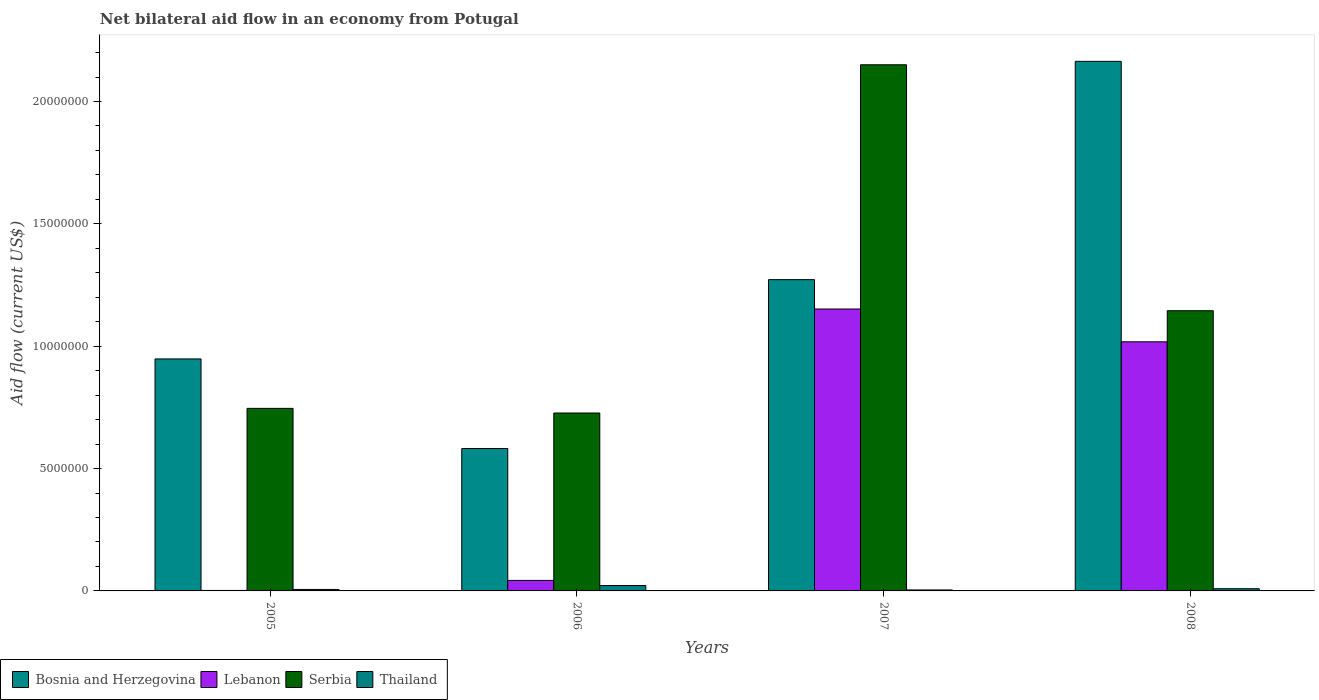How many different coloured bars are there?
Make the answer very short. 4. How many groups of bars are there?
Keep it short and to the point. 4. Are the number of bars per tick equal to the number of legend labels?
Provide a succinct answer. Yes. What is the label of the 3rd group of bars from the left?
Your answer should be compact. 2007. In how many cases, is the number of bars for a given year not equal to the number of legend labels?
Provide a short and direct response. 0. What is the net bilateral aid flow in Bosnia and Herzegovina in 2007?
Keep it short and to the point. 1.27e+07. Across all years, what is the maximum net bilateral aid flow in Serbia?
Your answer should be compact. 2.15e+07. Across all years, what is the minimum net bilateral aid flow in Bosnia and Herzegovina?
Offer a terse response. 5.82e+06. In which year was the net bilateral aid flow in Bosnia and Herzegovina maximum?
Give a very brief answer. 2008. What is the total net bilateral aid flow in Bosnia and Herzegovina in the graph?
Ensure brevity in your answer.  4.97e+07. What is the difference between the net bilateral aid flow in Bosnia and Herzegovina in 2007 and that in 2008?
Offer a very short reply. -8.92e+06. What is the difference between the net bilateral aid flow in Serbia in 2008 and the net bilateral aid flow in Thailand in 2006?
Give a very brief answer. 1.12e+07. What is the average net bilateral aid flow in Lebanon per year?
Keep it short and to the point. 5.54e+06. In the year 2006, what is the difference between the net bilateral aid flow in Bosnia and Herzegovina and net bilateral aid flow in Serbia?
Offer a very short reply. -1.45e+06. In how many years, is the net bilateral aid flow in Thailand greater than 10000000 US$?
Keep it short and to the point. 0. What is the difference between the highest and the second highest net bilateral aid flow in Bosnia and Herzegovina?
Keep it short and to the point. 8.92e+06. What is the difference between the highest and the lowest net bilateral aid flow in Bosnia and Herzegovina?
Give a very brief answer. 1.58e+07. Is the sum of the net bilateral aid flow in Serbia in 2005 and 2008 greater than the maximum net bilateral aid flow in Bosnia and Herzegovina across all years?
Ensure brevity in your answer.  No. What does the 3rd bar from the left in 2005 represents?
Offer a terse response. Serbia. What does the 4th bar from the right in 2008 represents?
Offer a very short reply. Bosnia and Herzegovina. Are all the bars in the graph horizontal?
Give a very brief answer. No. Does the graph contain grids?
Make the answer very short. No. How many legend labels are there?
Your answer should be very brief. 4. How are the legend labels stacked?
Make the answer very short. Horizontal. What is the title of the graph?
Ensure brevity in your answer.  Net bilateral aid flow in an economy from Potugal. Does "New Caledonia" appear as one of the legend labels in the graph?
Offer a terse response. No. What is the label or title of the X-axis?
Keep it short and to the point. Years. What is the label or title of the Y-axis?
Give a very brief answer. Aid flow (current US$). What is the Aid flow (current US$) of Bosnia and Herzegovina in 2005?
Keep it short and to the point. 9.48e+06. What is the Aid flow (current US$) in Lebanon in 2005?
Keep it short and to the point. 2.00e+04. What is the Aid flow (current US$) of Serbia in 2005?
Your answer should be very brief. 7.46e+06. What is the Aid flow (current US$) of Thailand in 2005?
Provide a short and direct response. 6.00e+04. What is the Aid flow (current US$) of Bosnia and Herzegovina in 2006?
Ensure brevity in your answer.  5.82e+06. What is the Aid flow (current US$) in Serbia in 2006?
Offer a very short reply. 7.27e+06. What is the Aid flow (current US$) in Thailand in 2006?
Make the answer very short. 2.20e+05. What is the Aid flow (current US$) of Bosnia and Herzegovina in 2007?
Your answer should be very brief. 1.27e+07. What is the Aid flow (current US$) of Lebanon in 2007?
Your answer should be compact. 1.15e+07. What is the Aid flow (current US$) in Serbia in 2007?
Your response must be concise. 2.15e+07. What is the Aid flow (current US$) in Bosnia and Herzegovina in 2008?
Ensure brevity in your answer.  2.16e+07. What is the Aid flow (current US$) in Lebanon in 2008?
Ensure brevity in your answer.  1.02e+07. What is the Aid flow (current US$) of Serbia in 2008?
Provide a succinct answer. 1.14e+07. Across all years, what is the maximum Aid flow (current US$) of Bosnia and Herzegovina?
Give a very brief answer. 2.16e+07. Across all years, what is the maximum Aid flow (current US$) in Lebanon?
Give a very brief answer. 1.15e+07. Across all years, what is the maximum Aid flow (current US$) of Serbia?
Keep it short and to the point. 2.15e+07. Across all years, what is the maximum Aid flow (current US$) in Thailand?
Provide a succinct answer. 2.20e+05. Across all years, what is the minimum Aid flow (current US$) of Bosnia and Herzegovina?
Keep it short and to the point. 5.82e+06. Across all years, what is the minimum Aid flow (current US$) of Lebanon?
Make the answer very short. 2.00e+04. Across all years, what is the minimum Aid flow (current US$) in Serbia?
Keep it short and to the point. 7.27e+06. Across all years, what is the minimum Aid flow (current US$) in Thailand?
Give a very brief answer. 4.00e+04. What is the total Aid flow (current US$) in Bosnia and Herzegovina in the graph?
Provide a short and direct response. 4.97e+07. What is the total Aid flow (current US$) of Lebanon in the graph?
Offer a terse response. 2.22e+07. What is the total Aid flow (current US$) in Serbia in the graph?
Keep it short and to the point. 4.77e+07. What is the total Aid flow (current US$) in Thailand in the graph?
Give a very brief answer. 4.10e+05. What is the difference between the Aid flow (current US$) of Bosnia and Herzegovina in 2005 and that in 2006?
Keep it short and to the point. 3.66e+06. What is the difference between the Aid flow (current US$) of Lebanon in 2005 and that in 2006?
Your answer should be compact. -4.10e+05. What is the difference between the Aid flow (current US$) of Serbia in 2005 and that in 2006?
Keep it short and to the point. 1.90e+05. What is the difference between the Aid flow (current US$) in Thailand in 2005 and that in 2006?
Your answer should be very brief. -1.60e+05. What is the difference between the Aid flow (current US$) in Bosnia and Herzegovina in 2005 and that in 2007?
Offer a terse response. -3.24e+06. What is the difference between the Aid flow (current US$) in Lebanon in 2005 and that in 2007?
Provide a succinct answer. -1.15e+07. What is the difference between the Aid flow (current US$) of Serbia in 2005 and that in 2007?
Offer a terse response. -1.40e+07. What is the difference between the Aid flow (current US$) in Thailand in 2005 and that in 2007?
Offer a very short reply. 2.00e+04. What is the difference between the Aid flow (current US$) in Bosnia and Herzegovina in 2005 and that in 2008?
Ensure brevity in your answer.  -1.22e+07. What is the difference between the Aid flow (current US$) of Lebanon in 2005 and that in 2008?
Ensure brevity in your answer.  -1.02e+07. What is the difference between the Aid flow (current US$) in Serbia in 2005 and that in 2008?
Provide a succinct answer. -3.99e+06. What is the difference between the Aid flow (current US$) in Bosnia and Herzegovina in 2006 and that in 2007?
Your answer should be very brief. -6.90e+06. What is the difference between the Aid flow (current US$) in Lebanon in 2006 and that in 2007?
Ensure brevity in your answer.  -1.11e+07. What is the difference between the Aid flow (current US$) in Serbia in 2006 and that in 2007?
Your response must be concise. -1.42e+07. What is the difference between the Aid flow (current US$) of Bosnia and Herzegovina in 2006 and that in 2008?
Make the answer very short. -1.58e+07. What is the difference between the Aid flow (current US$) of Lebanon in 2006 and that in 2008?
Give a very brief answer. -9.75e+06. What is the difference between the Aid flow (current US$) in Serbia in 2006 and that in 2008?
Provide a short and direct response. -4.18e+06. What is the difference between the Aid flow (current US$) in Thailand in 2006 and that in 2008?
Your response must be concise. 1.30e+05. What is the difference between the Aid flow (current US$) of Bosnia and Herzegovina in 2007 and that in 2008?
Your response must be concise. -8.92e+06. What is the difference between the Aid flow (current US$) of Lebanon in 2007 and that in 2008?
Provide a short and direct response. 1.34e+06. What is the difference between the Aid flow (current US$) of Serbia in 2007 and that in 2008?
Your response must be concise. 1.00e+07. What is the difference between the Aid flow (current US$) of Bosnia and Herzegovina in 2005 and the Aid flow (current US$) of Lebanon in 2006?
Your response must be concise. 9.05e+06. What is the difference between the Aid flow (current US$) in Bosnia and Herzegovina in 2005 and the Aid flow (current US$) in Serbia in 2006?
Provide a short and direct response. 2.21e+06. What is the difference between the Aid flow (current US$) of Bosnia and Herzegovina in 2005 and the Aid flow (current US$) of Thailand in 2006?
Make the answer very short. 9.26e+06. What is the difference between the Aid flow (current US$) in Lebanon in 2005 and the Aid flow (current US$) in Serbia in 2006?
Provide a short and direct response. -7.25e+06. What is the difference between the Aid flow (current US$) of Lebanon in 2005 and the Aid flow (current US$) of Thailand in 2006?
Offer a terse response. -2.00e+05. What is the difference between the Aid flow (current US$) of Serbia in 2005 and the Aid flow (current US$) of Thailand in 2006?
Your response must be concise. 7.24e+06. What is the difference between the Aid flow (current US$) in Bosnia and Herzegovina in 2005 and the Aid flow (current US$) in Lebanon in 2007?
Provide a short and direct response. -2.04e+06. What is the difference between the Aid flow (current US$) in Bosnia and Herzegovina in 2005 and the Aid flow (current US$) in Serbia in 2007?
Offer a very short reply. -1.20e+07. What is the difference between the Aid flow (current US$) of Bosnia and Herzegovina in 2005 and the Aid flow (current US$) of Thailand in 2007?
Ensure brevity in your answer.  9.44e+06. What is the difference between the Aid flow (current US$) in Lebanon in 2005 and the Aid flow (current US$) in Serbia in 2007?
Keep it short and to the point. -2.15e+07. What is the difference between the Aid flow (current US$) of Serbia in 2005 and the Aid flow (current US$) of Thailand in 2007?
Offer a terse response. 7.42e+06. What is the difference between the Aid flow (current US$) in Bosnia and Herzegovina in 2005 and the Aid flow (current US$) in Lebanon in 2008?
Offer a terse response. -7.00e+05. What is the difference between the Aid flow (current US$) of Bosnia and Herzegovina in 2005 and the Aid flow (current US$) of Serbia in 2008?
Make the answer very short. -1.97e+06. What is the difference between the Aid flow (current US$) in Bosnia and Herzegovina in 2005 and the Aid flow (current US$) in Thailand in 2008?
Provide a succinct answer. 9.39e+06. What is the difference between the Aid flow (current US$) in Lebanon in 2005 and the Aid flow (current US$) in Serbia in 2008?
Provide a succinct answer. -1.14e+07. What is the difference between the Aid flow (current US$) in Serbia in 2005 and the Aid flow (current US$) in Thailand in 2008?
Keep it short and to the point. 7.37e+06. What is the difference between the Aid flow (current US$) of Bosnia and Herzegovina in 2006 and the Aid flow (current US$) of Lebanon in 2007?
Ensure brevity in your answer.  -5.70e+06. What is the difference between the Aid flow (current US$) in Bosnia and Herzegovina in 2006 and the Aid flow (current US$) in Serbia in 2007?
Ensure brevity in your answer.  -1.57e+07. What is the difference between the Aid flow (current US$) in Bosnia and Herzegovina in 2006 and the Aid flow (current US$) in Thailand in 2007?
Provide a short and direct response. 5.78e+06. What is the difference between the Aid flow (current US$) in Lebanon in 2006 and the Aid flow (current US$) in Serbia in 2007?
Make the answer very short. -2.11e+07. What is the difference between the Aid flow (current US$) in Serbia in 2006 and the Aid flow (current US$) in Thailand in 2007?
Make the answer very short. 7.23e+06. What is the difference between the Aid flow (current US$) of Bosnia and Herzegovina in 2006 and the Aid flow (current US$) of Lebanon in 2008?
Your answer should be very brief. -4.36e+06. What is the difference between the Aid flow (current US$) in Bosnia and Herzegovina in 2006 and the Aid flow (current US$) in Serbia in 2008?
Give a very brief answer. -5.63e+06. What is the difference between the Aid flow (current US$) in Bosnia and Herzegovina in 2006 and the Aid flow (current US$) in Thailand in 2008?
Your answer should be compact. 5.73e+06. What is the difference between the Aid flow (current US$) of Lebanon in 2006 and the Aid flow (current US$) of Serbia in 2008?
Your answer should be compact. -1.10e+07. What is the difference between the Aid flow (current US$) of Serbia in 2006 and the Aid flow (current US$) of Thailand in 2008?
Your response must be concise. 7.18e+06. What is the difference between the Aid flow (current US$) of Bosnia and Herzegovina in 2007 and the Aid flow (current US$) of Lebanon in 2008?
Your answer should be very brief. 2.54e+06. What is the difference between the Aid flow (current US$) in Bosnia and Herzegovina in 2007 and the Aid flow (current US$) in Serbia in 2008?
Provide a short and direct response. 1.27e+06. What is the difference between the Aid flow (current US$) of Bosnia and Herzegovina in 2007 and the Aid flow (current US$) of Thailand in 2008?
Offer a terse response. 1.26e+07. What is the difference between the Aid flow (current US$) of Lebanon in 2007 and the Aid flow (current US$) of Serbia in 2008?
Offer a very short reply. 7.00e+04. What is the difference between the Aid flow (current US$) of Lebanon in 2007 and the Aid flow (current US$) of Thailand in 2008?
Provide a short and direct response. 1.14e+07. What is the difference between the Aid flow (current US$) in Serbia in 2007 and the Aid flow (current US$) in Thailand in 2008?
Provide a succinct answer. 2.14e+07. What is the average Aid flow (current US$) in Bosnia and Herzegovina per year?
Make the answer very short. 1.24e+07. What is the average Aid flow (current US$) of Lebanon per year?
Give a very brief answer. 5.54e+06. What is the average Aid flow (current US$) in Serbia per year?
Give a very brief answer. 1.19e+07. What is the average Aid flow (current US$) of Thailand per year?
Make the answer very short. 1.02e+05. In the year 2005, what is the difference between the Aid flow (current US$) of Bosnia and Herzegovina and Aid flow (current US$) of Lebanon?
Your answer should be compact. 9.46e+06. In the year 2005, what is the difference between the Aid flow (current US$) in Bosnia and Herzegovina and Aid flow (current US$) in Serbia?
Make the answer very short. 2.02e+06. In the year 2005, what is the difference between the Aid flow (current US$) in Bosnia and Herzegovina and Aid flow (current US$) in Thailand?
Give a very brief answer. 9.42e+06. In the year 2005, what is the difference between the Aid flow (current US$) in Lebanon and Aid flow (current US$) in Serbia?
Make the answer very short. -7.44e+06. In the year 2005, what is the difference between the Aid flow (current US$) in Serbia and Aid flow (current US$) in Thailand?
Give a very brief answer. 7.40e+06. In the year 2006, what is the difference between the Aid flow (current US$) of Bosnia and Herzegovina and Aid flow (current US$) of Lebanon?
Make the answer very short. 5.39e+06. In the year 2006, what is the difference between the Aid flow (current US$) of Bosnia and Herzegovina and Aid flow (current US$) of Serbia?
Provide a short and direct response. -1.45e+06. In the year 2006, what is the difference between the Aid flow (current US$) in Bosnia and Herzegovina and Aid flow (current US$) in Thailand?
Your response must be concise. 5.60e+06. In the year 2006, what is the difference between the Aid flow (current US$) of Lebanon and Aid flow (current US$) of Serbia?
Make the answer very short. -6.84e+06. In the year 2006, what is the difference between the Aid flow (current US$) of Lebanon and Aid flow (current US$) of Thailand?
Offer a terse response. 2.10e+05. In the year 2006, what is the difference between the Aid flow (current US$) in Serbia and Aid flow (current US$) in Thailand?
Provide a short and direct response. 7.05e+06. In the year 2007, what is the difference between the Aid flow (current US$) of Bosnia and Herzegovina and Aid flow (current US$) of Lebanon?
Provide a short and direct response. 1.20e+06. In the year 2007, what is the difference between the Aid flow (current US$) of Bosnia and Herzegovina and Aid flow (current US$) of Serbia?
Provide a succinct answer. -8.78e+06. In the year 2007, what is the difference between the Aid flow (current US$) in Bosnia and Herzegovina and Aid flow (current US$) in Thailand?
Offer a very short reply. 1.27e+07. In the year 2007, what is the difference between the Aid flow (current US$) of Lebanon and Aid flow (current US$) of Serbia?
Make the answer very short. -9.98e+06. In the year 2007, what is the difference between the Aid flow (current US$) in Lebanon and Aid flow (current US$) in Thailand?
Offer a terse response. 1.15e+07. In the year 2007, what is the difference between the Aid flow (current US$) in Serbia and Aid flow (current US$) in Thailand?
Give a very brief answer. 2.15e+07. In the year 2008, what is the difference between the Aid flow (current US$) in Bosnia and Herzegovina and Aid flow (current US$) in Lebanon?
Make the answer very short. 1.15e+07. In the year 2008, what is the difference between the Aid flow (current US$) in Bosnia and Herzegovina and Aid flow (current US$) in Serbia?
Make the answer very short. 1.02e+07. In the year 2008, what is the difference between the Aid flow (current US$) in Bosnia and Herzegovina and Aid flow (current US$) in Thailand?
Make the answer very short. 2.16e+07. In the year 2008, what is the difference between the Aid flow (current US$) in Lebanon and Aid flow (current US$) in Serbia?
Provide a succinct answer. -1.27e+06. In the year 2008, what is the difference between the Aid flow (current US$) in Lebanon and Aid flow (current US$) in Thailand?
Your answer should be compact. 1.01e+07. In the year 2008, what is the difference between the Aid flow (current US$) of Serbia and Aid flow (current US$) of Thailand?
Your response must be concise. 1.14e+07. What is the ratio of the Aid flow (current US$) in Bosnia and Herzegovina in 2005 to that in 2006?
Your answer should be compact. 1.63. What is the ratio of the Aid flow (current US$) of Lebanon in 2005 to that in 2006?
Give a very brief answer. 0.05. What is the ratio of the Aid flow (current US$) in Serbia in 2005 to that in 2006?
Keep it short and to the point. 1.03. What is the ratio of the Aid flow (current US$) in Thailand in 2005 to that in 2006?
Keep it short and to the point. 0.27. What is the ratio of the Aid flow (current US$) of Bosnia and Herzegovina in 2005 to that in 2007?
Ensure brevity in your answer.  0.75. What is the ratio of the Aid flow (current US$) in Lebanon in 2005 to that in 2007?
Provide a short and direct response. 0. What is the ratio of the Aid flow (current US$) of Serbia in 2005 to that in 2007?
Keep it short and to the point. 0.35. What is the ratio of the Aid flow (current US$) in Thailand in 2005 to that in 2007?
Keep it short and to the point. 1.5. What is the ratio of the Aid flow (current US$) of Bosnia and Herzegovina in 2005 to that in 2008?
Keep it short and to the point. 0.44. What is the ratio of the Aid flow (current US$) in Lebanon in 2005 to that in 2008?
Provide a succinct answer. 0. What is the ratio of the Aid flow (current US$) in Serbia in 2005 to that in 2008?
Provide a short and direct response. 0.65. What is the ratio of the Aid flow (current US$) in Thailand in 2005 to that in 2008?
Make the answer very short. 0.67. What is the ratio of the Aid flow (current US$) in Bosnia and Herzegovina in 2006 to that in 2007?
Your answer should be compact. 0.46. What is the ratio of the Aid flow (current US$) of Lebanon in 2006 to that in 2007?
Offer a very short reply. 0.04. What is the ratio of the Aid flow (current US$) in Serbia in 2006 to that in 2007?
Give a very brief answer. 0.34. What is the ratio of the Aid flow (current US$) in Thailand in 2006 to that in 2007?
Provide a succinct answer. 5.5. What is the ratio of the Aid flow (current US$) of Bosnia and Herzegovina in 2006 to that in 2008?
Your answer should be compact. 0.27. What is the ratio of the Aid flow (current US$) in Lebanon in 2006 to that in 2008?
Provide a succinct answer. 0.04. What is the ratio of the Aid flow (current US$) in Serbia in 2006 to that in 2008?
Offer a terse response. 0.63. What is the ratio of the Aid flow (current US$) in Thailand in 2006 to that in 2008?
Ensure brevity in your answer.  2.44. What is the ratio of the Aid flow (current US$) in Bosnia and Herzegovina in 2007 to that in 2008?
Your response must be concise. 0.59. What is the ratio of the Aid flow (current US$) in Lebanon in 2007 to that in 2008?
Your response must be concise. 1.13. What is the ratio of the Aid flow (current US$) in Serbia in 2007 to that in 2008?
Provide a succinct answer. 1.88. What is the ratio of the Aid flow (current US$) in Thailand in 2007 to that in 2008?
Provide a short and direct response. 0.44. What is the difference between the highest and the second highest Aid flow (current US$) of Bosnia and Herzegovina?
Ensure brevity in your answer.  8.92e+06. What is the difference between the highest and the second highest Aid flow (current US$) in Lebanon?
Provide a short and direct response. 1.34e+06. What is the difference between the highest and the second highest Aid flow (current US$) of Serbia?
Your response must be concise. 1.00e+07. What is the difference between the highest and the lowest Aid flow (current US$) in Bosnia and Herzegovina?
Your answer should be compact. 1.58e+07. What is the difference between the highest and the lowest Aid flow (current US$) in Lebanon?
Give a very brief answer. 1.15e+07. What is the difference between the highest and the lowest Aid flow (current US$) in Serbia?
Ensure brevity in your answer.  1.42e+07. 